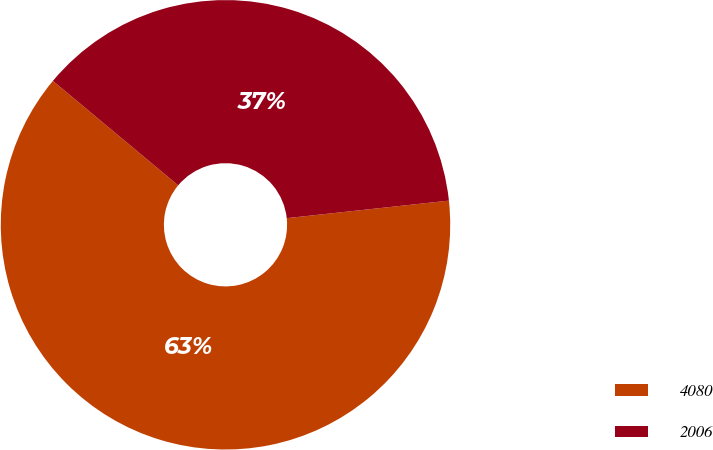Convert chart to OTSL. <chart><loc_0><loc_0><loc_500><loc_500><pie_chart><fcel>4080<fcel>2006<nl><fcel>62.78%<fcel>37.22%<nl></chart> 